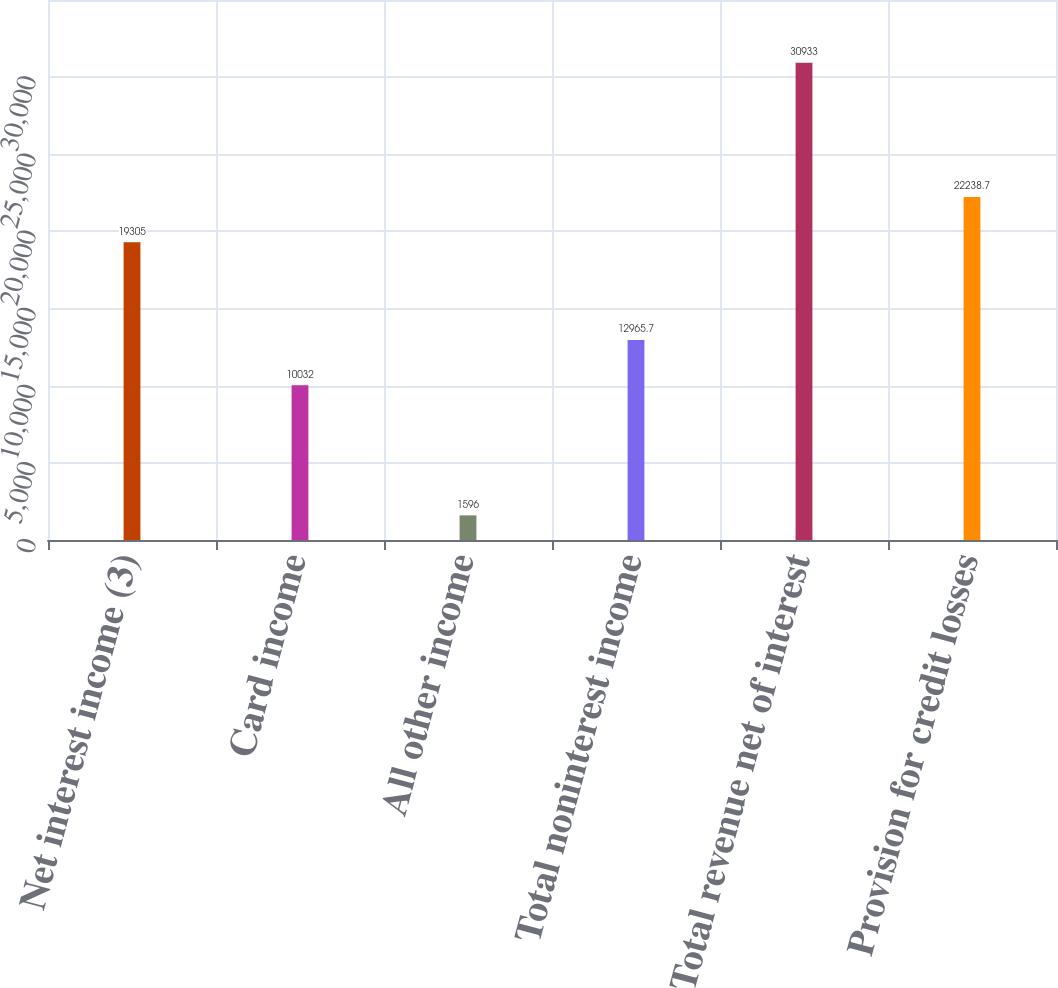<chart> <loc_0><loc_0><loc_500><loc_500><bar_chart><fcel>Net interest income (3)<fcel>Card income<fcel>All other income<fcel>Total noninterest income<fcel>Total revenue net of interest<fcel>Provision for credit losses<nl><fcel>19305<fcel>10032<fcel>1596<fcel>12965.7<fcel>30933<fcel>22238.7<nl></chart> 